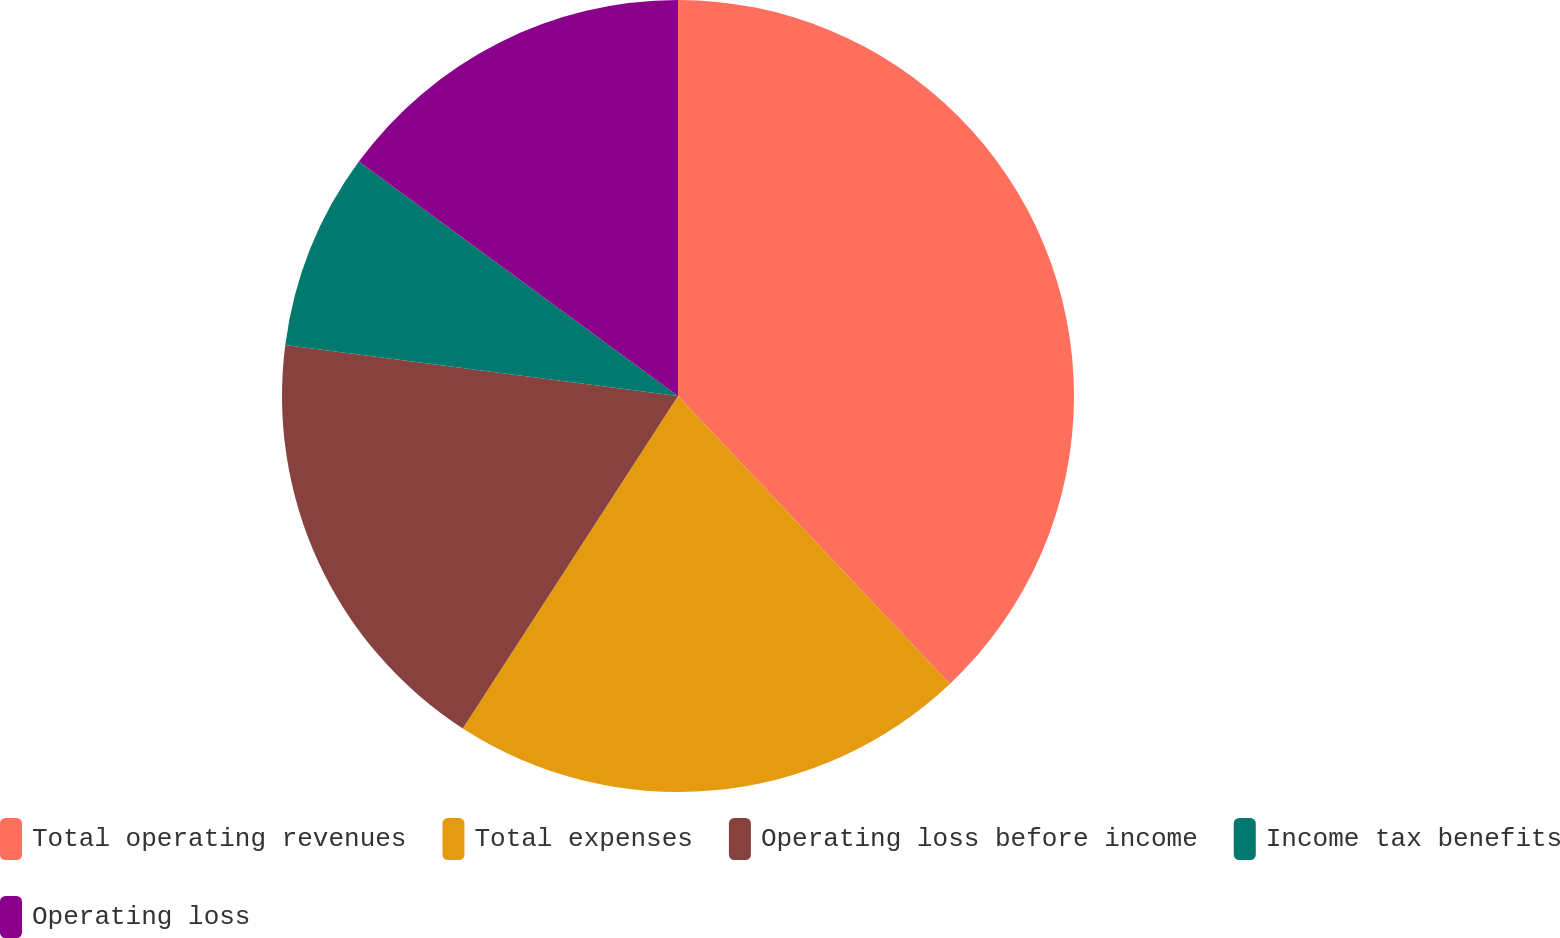Convert chart. <chart><loc_0><loc_0><loc_500><loc_500><pie_chart><fcel>Total operating revenues<fcel>Total expenses<fcel>Operating loss before income<fcel>Income tax benefits<fcel>Operating loss<nl><fcel>37.96%<fcel>21.19%<fcel>17.91%<fcel>8.03%<fcel>14.92%<nl></chart> 